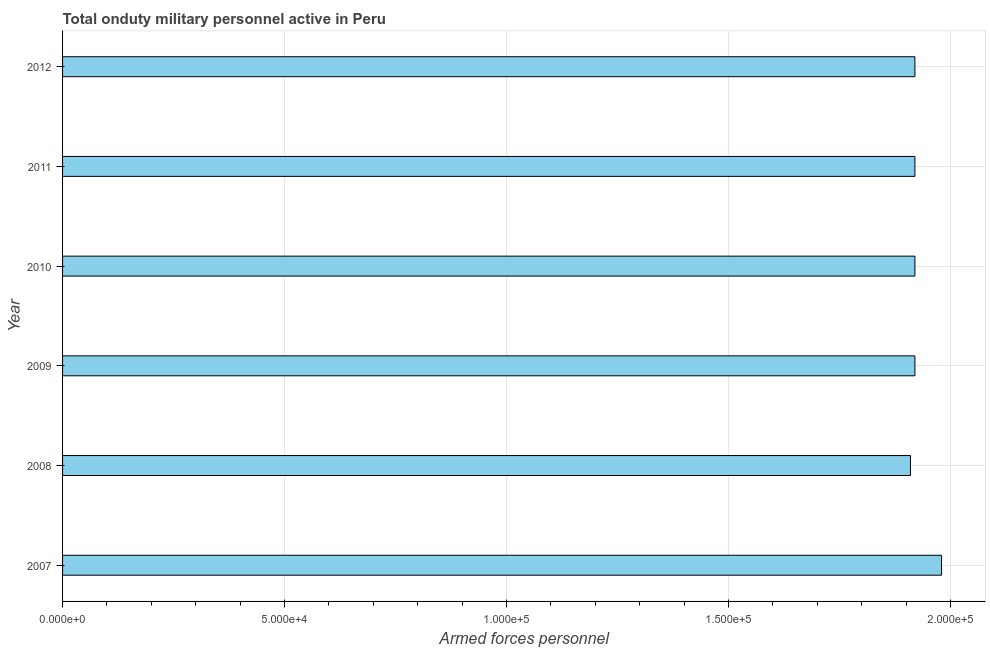Does the graph contain grids?
Keep it short and to the point. Yes. What is the title of the graph?
Provide a succinct answer. Total onduty military personnel active in Peru. What is the label or title of the X-axis?
Give a very brief answer. Armed forces personnel. What is the label or title of the Y-axis?
Provide a short and direct response. Year. What is the number of armed forces personnel in 2009?
Your answer should be very brief. 1.92e+05. Across all years, what is the maximum number of armed forces personnel?
Make the answer very short. 1.98e+05. Across all years, what is the minimum number of armed forces personnel?
Provide a succinct answer. 1.91e+05. What is the sum of the number of armed forces personnel?
Provide a short and direct response. 1.16e+06. What is the difference between the number of armed forces personnel in 2008 and 2010?
Keep it short and to the point. -1000. What is the average number of armed forces personnel per year?
Provide a succinct answer. 1.93e+05. What is the median number of armed forces personnel?
Your answer should be compact. 1.92e+05. What is the difference between the highest and the second highest number of armed forces personnel?
Offer a very short reply. 6000. Is the sum of the number of armed forces personnel in 2007 and 2009 greater than the maximum number of armed forces personnel across all years?
Make the answer very short. Yes. What is the difference between the highest and the lowest number of armed forces personnel?
Make the answer very short. 7000. How many bars are there?
Ensure brevity in your answer.  6. Are all the bars in the graph horizontal?
Offer a terse response. Yes. How many years are there in the graph?
Offer a terse response. 6. What is the difference between two consecutive major ticks on the X-axis?
Offer a terse response. 5.00e+04. What is the Armed forces personnel in 2007?
Make the answer very short. 1.98e+05. What is the Armed forces personnel of 2008?
Your answer should be very brief. 1.91e+05. What is the Armed forces personnel of 2009?
Ensure brevity in your answer.  1.92e+05. What is the Armed forces personnel of 2010?
Your response must be concise. 1.92e+05. What is the Armed forces personnel of 2011?
Make the answer very short. 1.92e+05. What is the Armed forces personnel of 2012?
Make the answer very short. 1.92e+05. What is the difference between the Armed forces personnel in 2007 and 2008?
Ensure brevity in your answer.  7000. What is the difference between the Armed forces personnel in 2007 and 2009?
Offer a terse response. 6000. What is the difference between the Armed forces personnel in 2007 and 2010?
Give a very brief answer. 6000. What is the difference between the Armed forces personnel in 2007 and 2011?
Your answer should be compact. 6000. What is the difference between the Armed forces personnel in 2007 and 2012?
Your answer should be compact. 6000. What is the difference between the Armed forces personnel in 2008 and 2009?
Provide a short and direct response. -1000. What is the difference between the Armed forces personnel in 2008 and 2010?
Offer a terse response. -1000. What is the difference between the Armed forces personnel in 2008 and 2011?
Ensure brevity in your answer.  -1000. What is the difference between the Armed forces personnel in 2008 and 2012?
Provide a succinct answer. -1000. What is the difference between the Armed forces personnel in 2009 and 2010?
Ensure brevity in your answer.  0. What is the difference between the Armed forces personnel in 2009 and 2011?
Make the answer very short. 0. What is the difference between the Armed forces personnel in 2010 and 2011?
Your response must be concise. 0. What is the difference between the Armed forces personnel in 2011 and 2012?
Your answer should be very brief. 0. What is the ratio of the Armed forces personnel in 2007 to that in 2008?
Your answer should be compact. 1.04. What is the ratio of the Armed forces personnel in 2007 to that in 2009?
Provide a succinct answer. 1.03. What is the ratio of the Armed forces personnel in 2007 to that in 2010?
Keep it short and to the point. 1.03. What is the ratio of the Armed forces personnel in 2007 to that in 2011?
Your response must be concise. 1.03. What is the ratio of the Armed forces personnel in 2007 to that in 2012?
Give a very brief answer. 1.03. What is the ratio of the Armed forces personnel in 2008 to that in 2009?
Make the answer very short. 0.99. What is the ratio of the Armed forces personnel in 2008 to that in 2011?
Provide a short and direct response. 0.99. What is the ratio of the Armed forces personnel in 2009 to that in 2012?
Make the answer very short. 1. What is the ratio of the Armed forces personnel in 2010 to that in 2011?
Your answer should be compact. 1. What is the ratio of the Armed forces personnel in 2010 to that in 2012?
Ensure brevity in your answer.  1. 